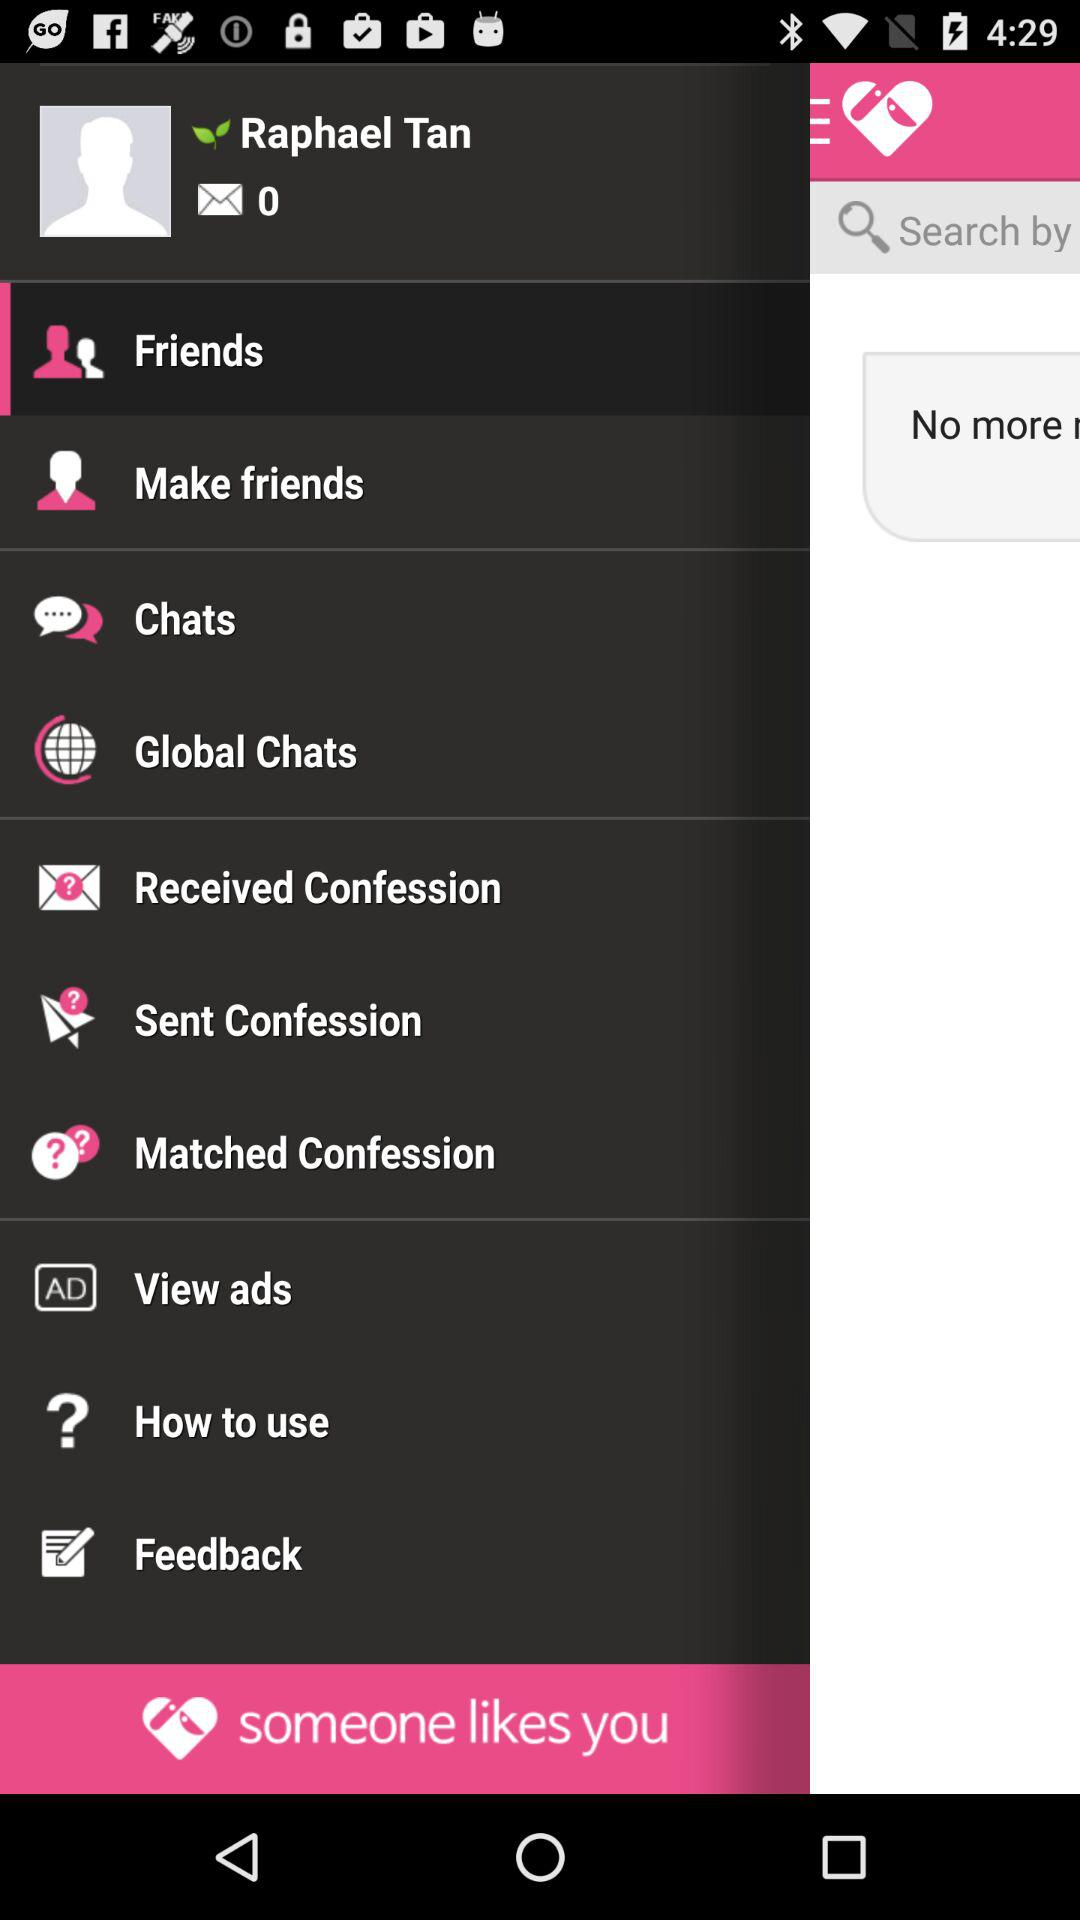How many messages are there? There are 0 messages. 